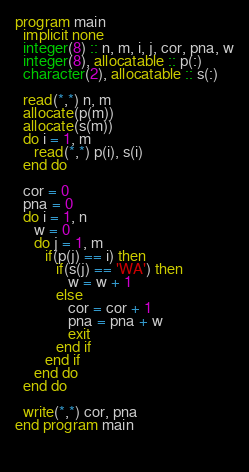<code> <loc_0><loc_0><loc_500><loc_500><_FORTRAN_>program main
  implicit none
  integer(8) :: n, m, i, j, cor, pna, w
  integer(8), allocatable :: p(:)
  character(2), allocatable :: s(:)

  read(*,*) n, m
  allocate(p(m))
  allocate(s(m))
  do i = 1, m
     read(*,*) p(i), s(i)
  end do

  cor = 0
  pna = 0
  do i = 1, n
     w = 0
     do j = 1, m
        if(p(j) == i) then
           if(s(j) == 'WA') then
              w = w + 1
           else
              cor = cor + 1
              pna = pna + w
              exit
           end if
        end if
     end do
  end do

  write(*,*) cor, pna
end program main

        
</code> 